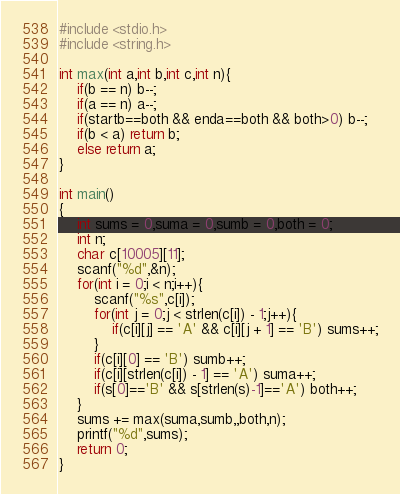Convert code to text. <code><loc_0><loc_0><loc_500><loc_500><_C_>#include <stdio.h>
#include <string.h>

int max(int a,int b,int c,int n){
	if(b == n) b--;
	if(a == n) a--;
	if(startb==both && enda==both && both>0) b--;
	if(b < a) return b;
	else return a;
}

int main()
{
	int sums = 0,suma = 0,sumb = 0,both = 0;
	int n;
	char c[10005][11];
	scanf("%d",&n);
	for(int i = 0;i < n;i++){
		scanf("%s",c[i]);
		for(int j = 0;j < strlen(c[i]) - 1;j++){
			if(c[i][j] == 'A' && c[i][j + 1] == 'B') sums++;
		}
		if(c[i][0] == 'B') sumb++;
		if(c[i][strlen(c[i]) - 1] == 'A') suma++;
		if(s[0]=='B' && s[strlen(s)-1]=='A') both++;
	}
	sums += max(suma,sumb,,both,n);
	printf("%d",sums);
	return 0;
}</code> 